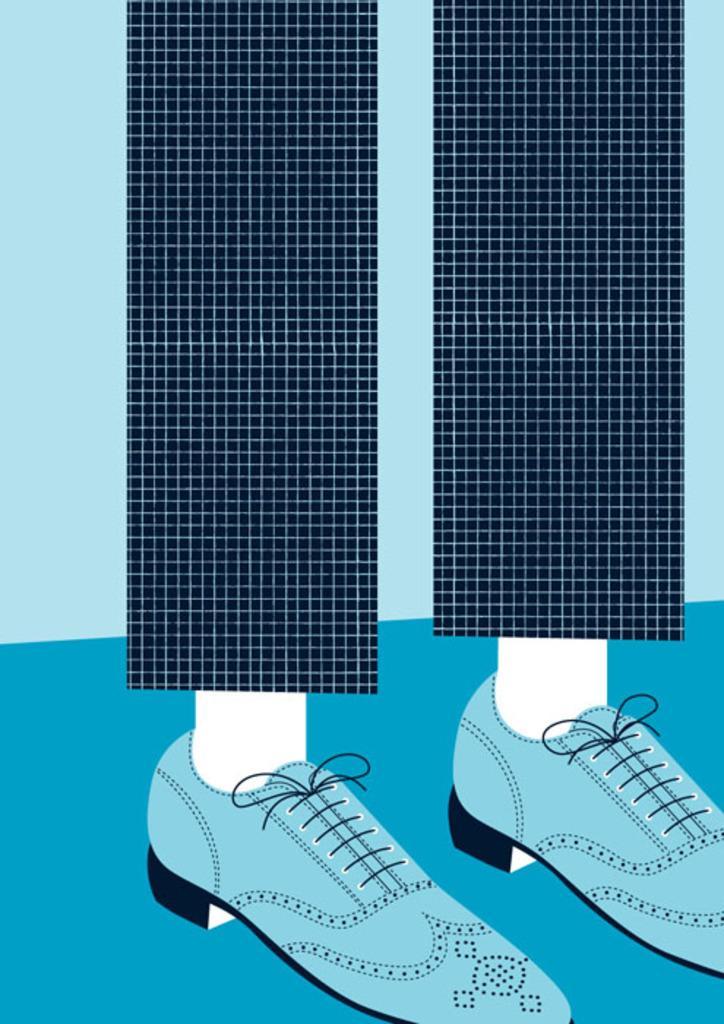How would you summarize this image in a sentence or two? In this image, we can see a painting of a person's leg, who is wearing trousers and shoes. The ground is blue in color. 